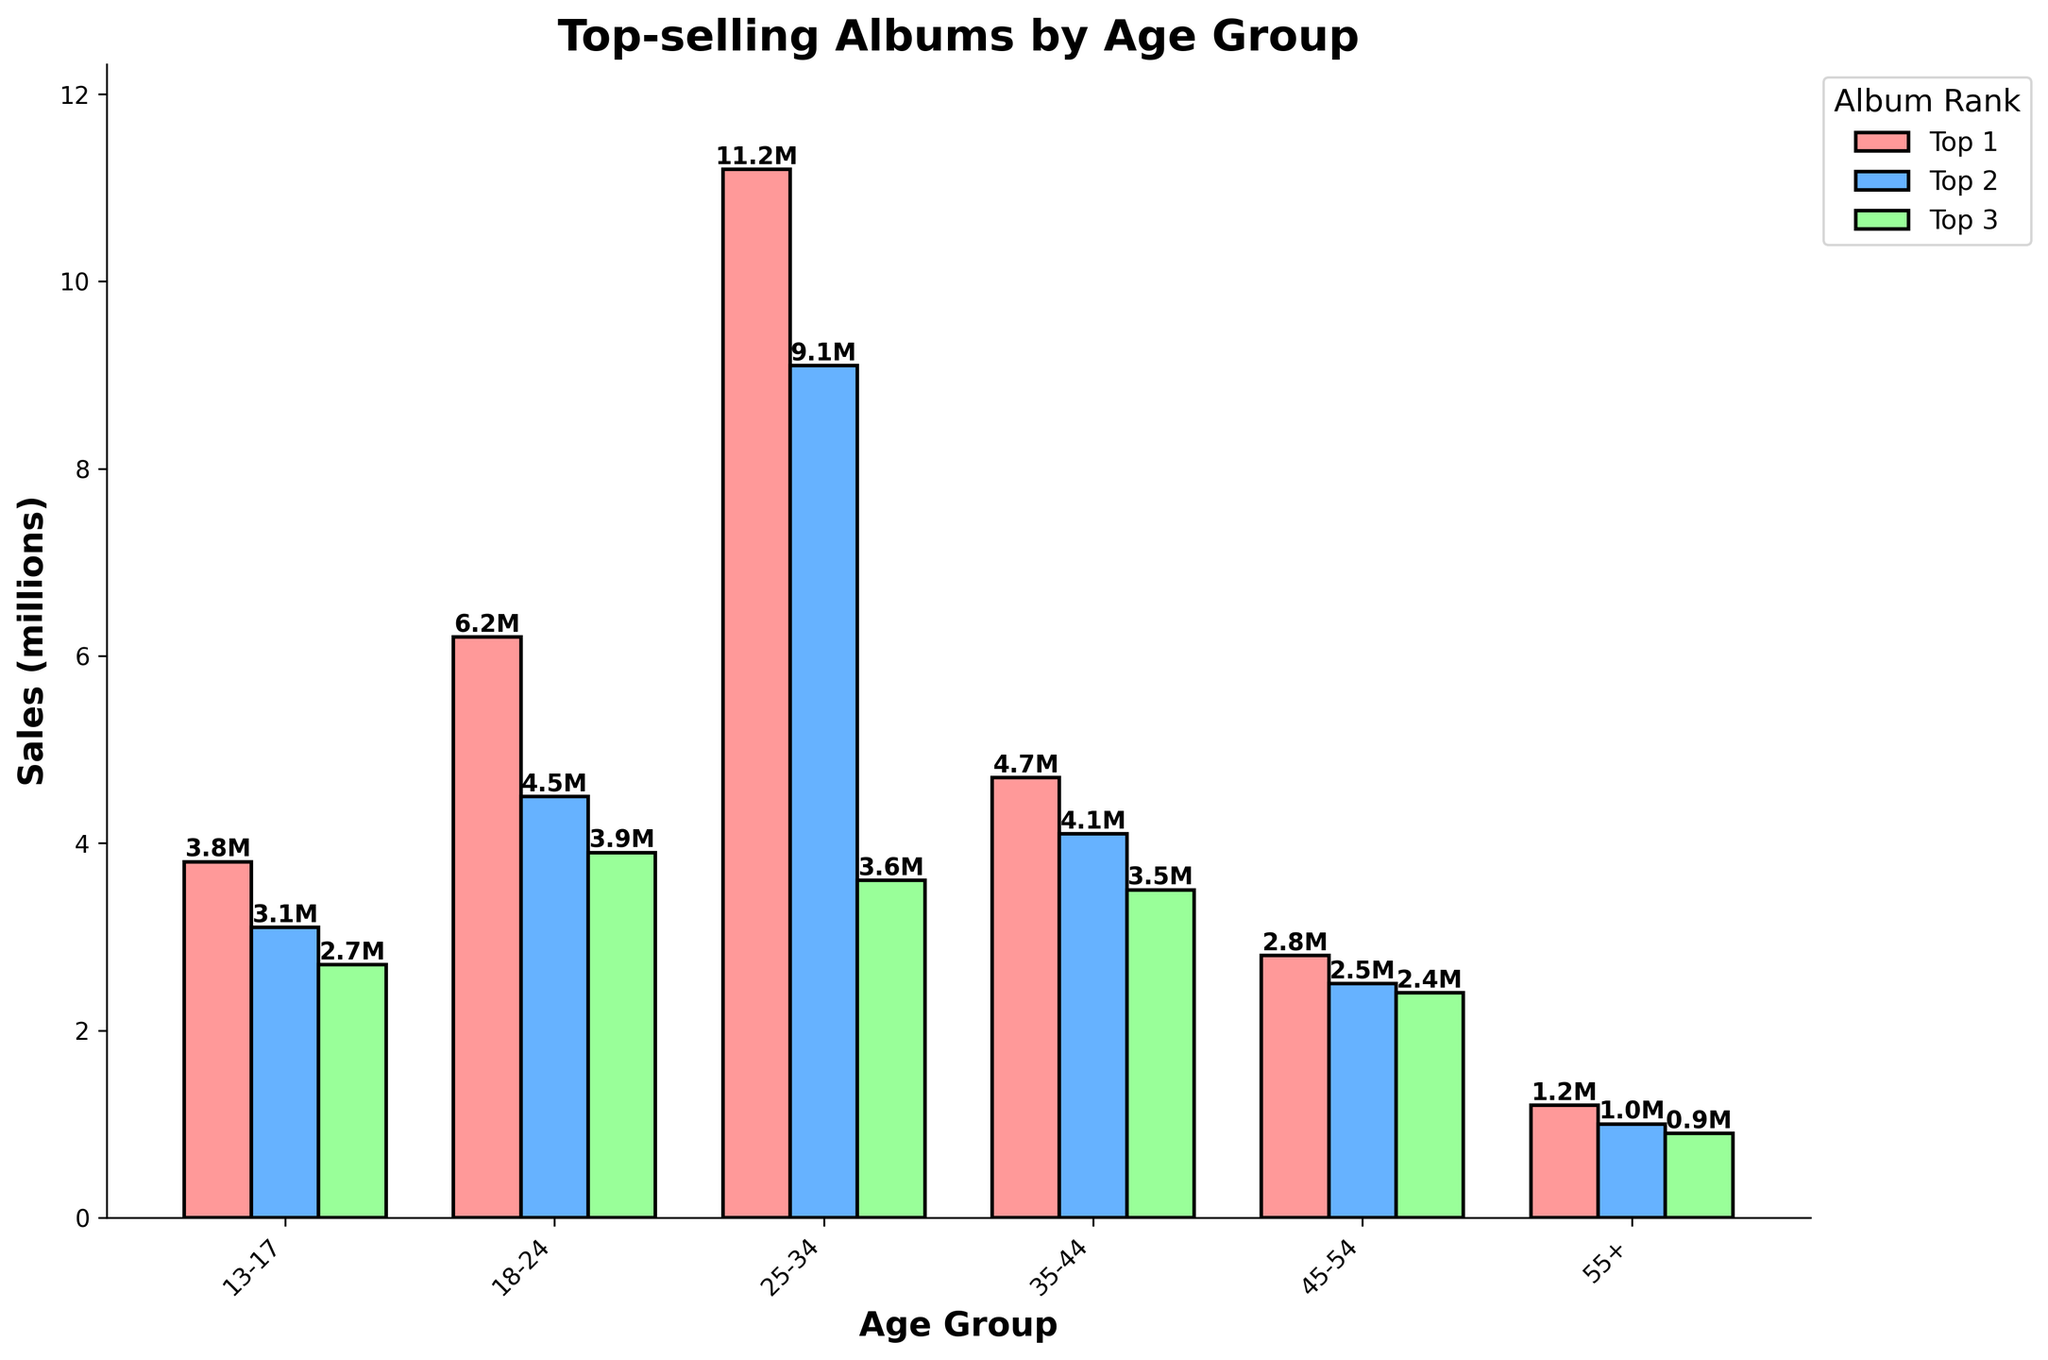Which age group has the highest album sales for the top-selling album? Look at the top bar in each age group and identify which one is the highest. The tallest bar corresponds to '21' by Adele in the 25-34 age group with 11.2 million sales.
Answer: 25-34 What is the combined sales of the top albums for the 13-17 and 18-24 age groups? Add the sales of the top album in the 13-17 age group (3.8 million) and the top album in the 18-24 age group (6.2 million). 3.8 + 6.2 = 10.0 million.
Answer: 10.0 million Which artist appears most frequently across the age groups and what are the sales for each album? Check the artists in the bar chart for each age group and count the occurrences. Compare the artist names to find which appears most frequently. Lady Gaga appears in the 45-54 and 55+ age groups with 'Born This Way' (2.5 million) and 'Joanne' (1.0 million).
Answer: Lady Gaga, 2.5 million, 1.0 million Which age group has the smallest difference between the top 3 album sales? Calculate the difference between the largest and smallest bar in each age group. Compare these differences. For the 45-54 age group: Pure Heroine 2.8 - The 20/20 Experience 2.4 = 0.4 million, which is the smallest difference.
Answer: 45-54 What is the average sales of the top 3 albums for the 35-44 age group? Add the sales of the top 3 albums in the 35-44 age group and divide by 3. (4.7 + 4.1 + 3.5) / 3 = 4.1 million.
Answer: 4.1 million Which album has the highest sales among listeners over 55? Identify the tallest bar within the 55+ age group and read its sales value. 'Wonderful Crazy Night' by Elton John with 1.2 million sales is the highest.
Answer: Wonderful Crazy Night What is the difference in sales between the most popular albums for the 25-34 and 35-44 age groups? Subtract the sales of the top album in the 35-44 group from the sales of the top album in the 25-34 group. 11.2 million (Adele's '21') - 4.7 million (Beyoncé's 'Lemonade') = 6.5 million.
Answer: 6.5 million Which age group has the lowest combined sales for their top 3 albums? Add the sales for the top 3 albums in each age group and compare. For 55+: 1.2 (Elton John) + 1.0 (Lady Gaga) + 0.9 (Madonna) = 3.1 million, which is the lowest combined total.
Answer: 55+ 